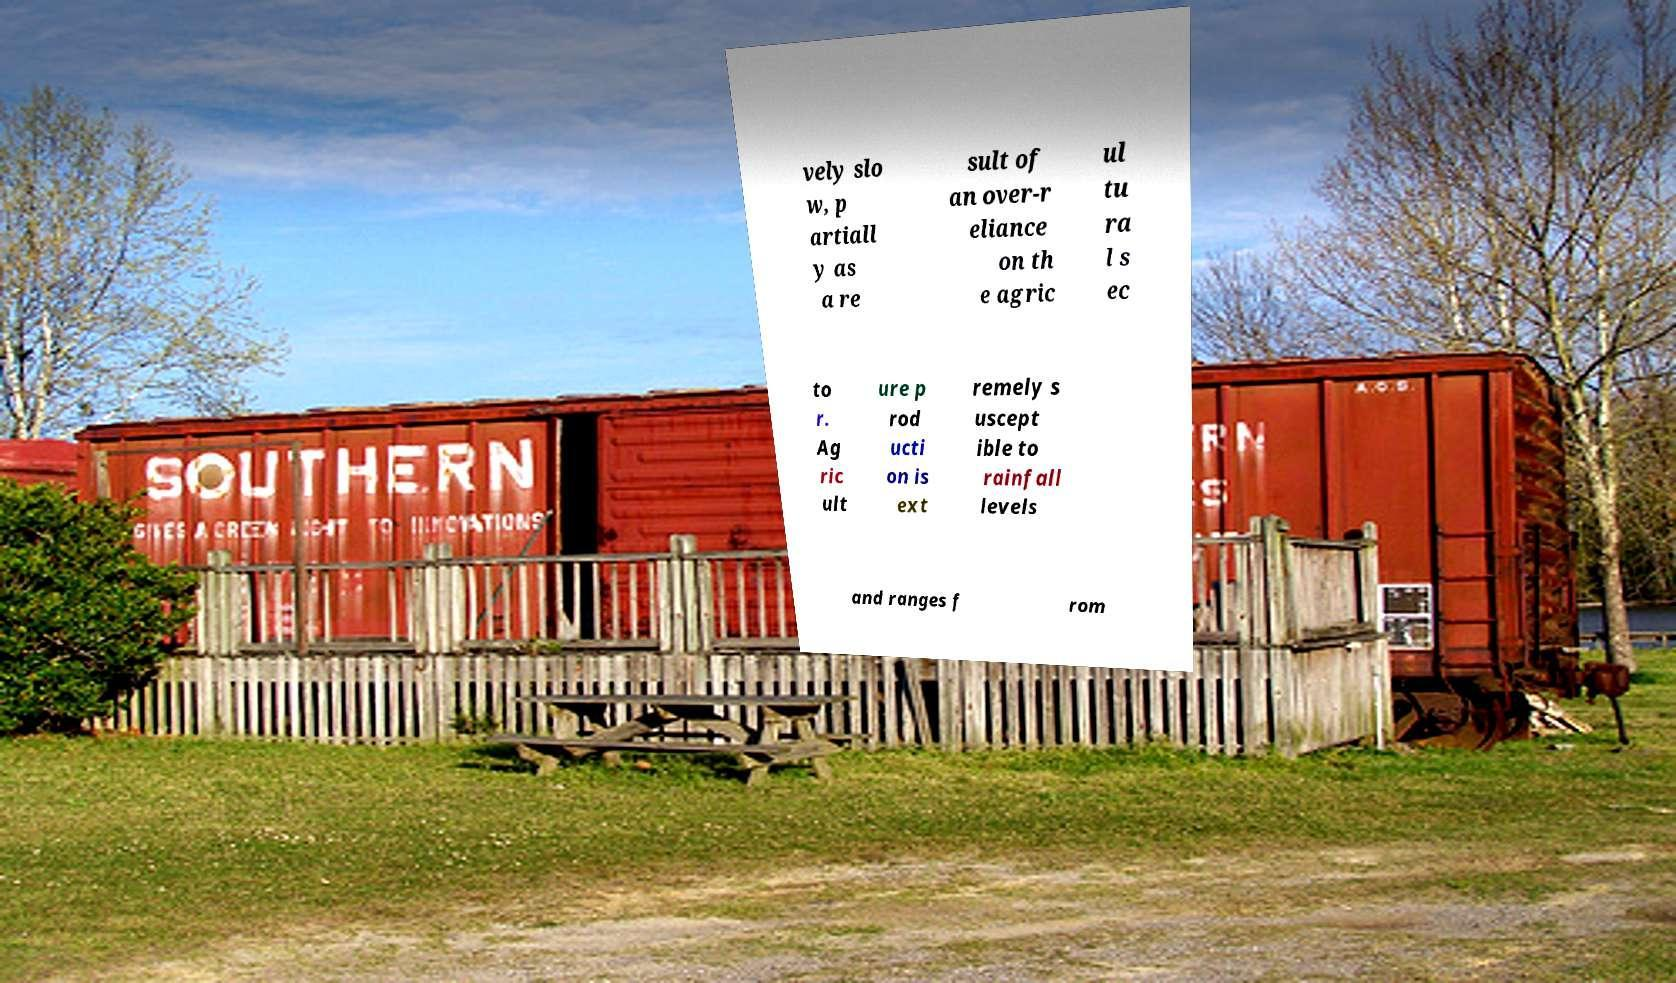Can you accurately transcribe the text from the provided image for me? vely slo w, p artiall y as a re sult of an over-r eliance on th e agric ul tu ra l s ec to r. Ag ric ult ure p rod ucti on is ext remely s uscept ible to rainfall levels and ranges f rom 